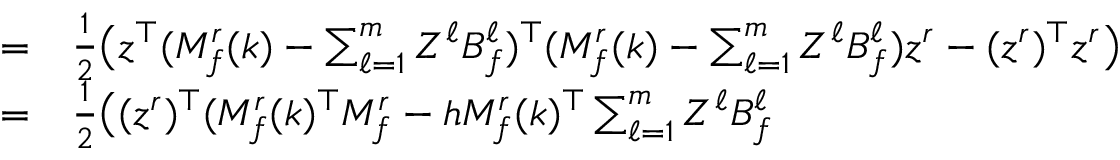Convert formula to latex. <formula><loc_0><loc_0><loc_500><loc_500>\begin{array} { r l } { = } & \frac { 1 } { 2 } \Big ( z ^ { \top } ( M _ { f } ^ { r } ( k ) - \sum _ { \ell = 1 } ^ { m } Z ^ { \ell } B _ { f } ^ { \ell } ) ^ { \top } ( M _ { f } ^ { r } ( k ) - \sum _ { \ell = 1 } ^ { m } Z ^ { \ell } B _ { f } ^ { \ell } ) z ^ { r } - ( z ^ { r } ) ^ { \top } z ^ { r } \Big ) } \\ { = } & \frac { 1 } { 2 } \Big ( ( z ^ { r } ) ^ { \top } ( M _ { f } ^ { r } ( k ) ^ { \top } M _ { f } ^ { r } - h M _ { f } ^ { r } ( k ) ^ { \top } \sum _ { \ell = 1 } ^ { m } Z ^ { \ell } B _ { f } ^ { \ell } } \end{array}</formula> 